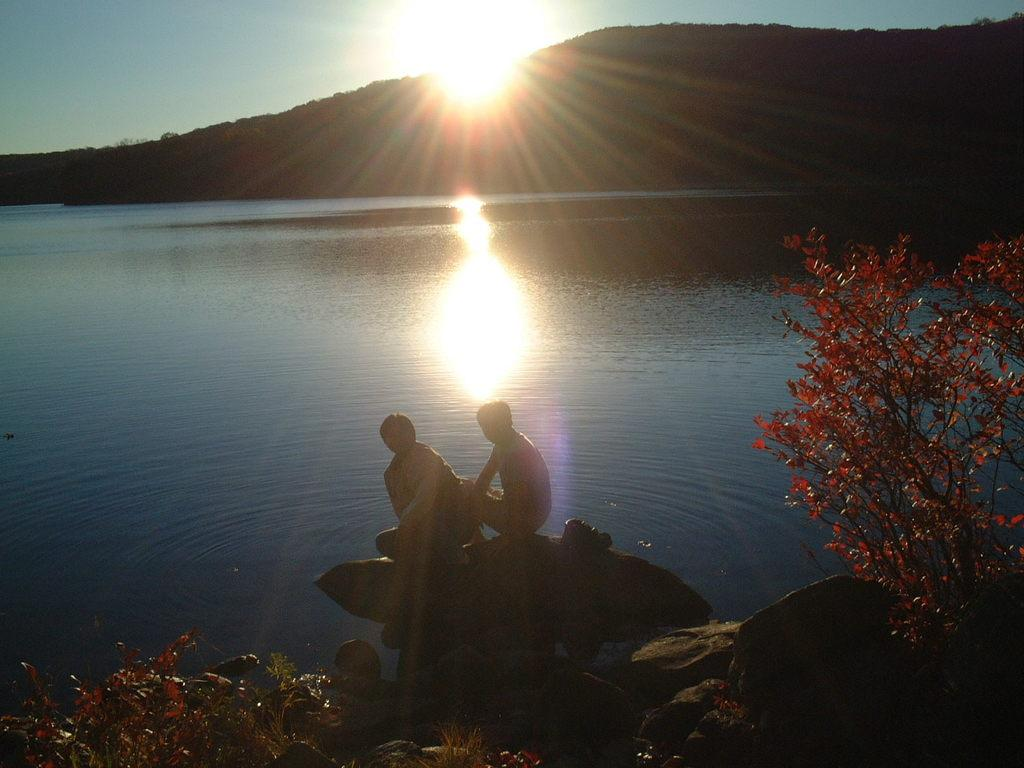How many people are sitting on the stone in the image? There are two persons sitting on a stone in the image. What can be seen on the left side of the image? There are plants on the left side of the image. What can be seen on the right side of the image? There are plants on the right side of the image. What is visible in the background of the image? There is a river and a mountain in the background of the image. What is the position of the sun in the sky? The sun is rising in the sky. What type of tools does the beast use to play music in the image? There is no beast or musical instruments present in the image. 